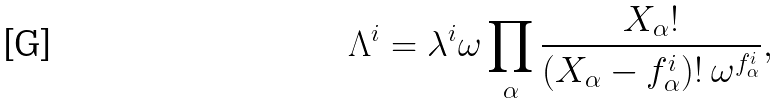Convert formula to latex. <formula><loc_0><loc_0><loc_500><loc_500>\Lambda ^ { i } = \lambda ^ { i } \omega \prod _ { \alpha } \frac { X _ { \alpha } ! } { ( X _ { \alpha } - f _ { \alpha } ^ { i } ) ! \ \omega ^ { f _ { \alpha } ^ { i } } } ,</formula> 